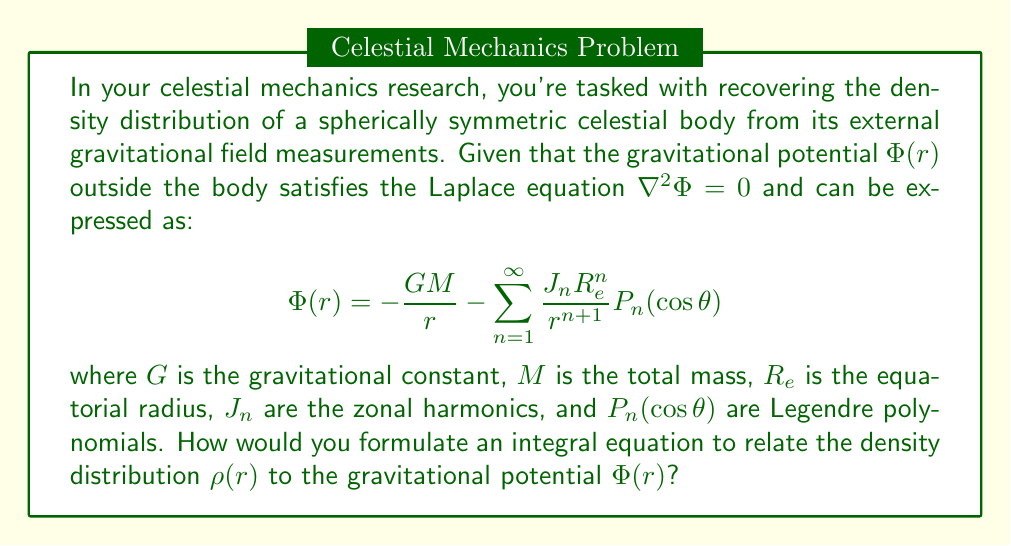Provide a solution to this math problem. To solve this inverse problem, we need to follow these steps:

1) First, recall that for a spherically symmetric body, the gravitational potential inside and outside the body is given by:

   $$\Phi(r) = -4\pi G \left[\frac{1}{r}\int_0^r \rho(r')r'^2 dr' + \int_r^{R_e} \rho(r')r' dr'\right]$$

2) The density distribution $\rho(r)$ is related to the mass distribution $m(r)$ by:

   $$m(r) = 4\pi \int_0^r \rho(r')r'^2 dr'$$

3) Taking the derivative of the potential with respect to $r$, we get:

   $$\frac{d\Phi}{dr} = -\frac{Gm(r)}{r^2}$$

4) Now, we can use the given expression for the external potential:

   $$\Phi(r) = -\frac{GM}{r} - \sum_{n=1}^{\infty} \frac{J_n R_e^n}{r^{n+1}} P_n(\cos\theta)$$

5) Taking the radial derivative and equating it with the expression from step 3:

   $$\frac{GM}{r^2} + \sum_{n=1}^{\infty} \frac{(n+1)J_n R_e^n}{r^{n+2}} P_n(\cos\theta) = \frac{Gm(r)}{r^2}$$

6) For a spherically symmetric body, we can ignore the angular dependence and focus on the $n=0$ term:

   $$M + \sum_{n=1}^{\infty} (n+1)J_n \left(\frac{R_e}{r}\right)^n = m(r)$$

7) Differentiating both sides with respect to $r$:

   $$-\sum_{n=1}^{\infty} n(n+1)J_n \frac{R_e^n}{r^{n+1}} = 4\pi r^2 \rho(r)$$

8) This is our integral equation relating the density distribution $\rho(r)$ to the gravitational potential (via the $J_n$ coefficients).
Answer: $\rho(r) = -\frac{1}{4\pi Gr^2} \sum_{n=1}^{\infty} n(n+1)J_n \frac{R_e^n}{r^{n+1}}$ 